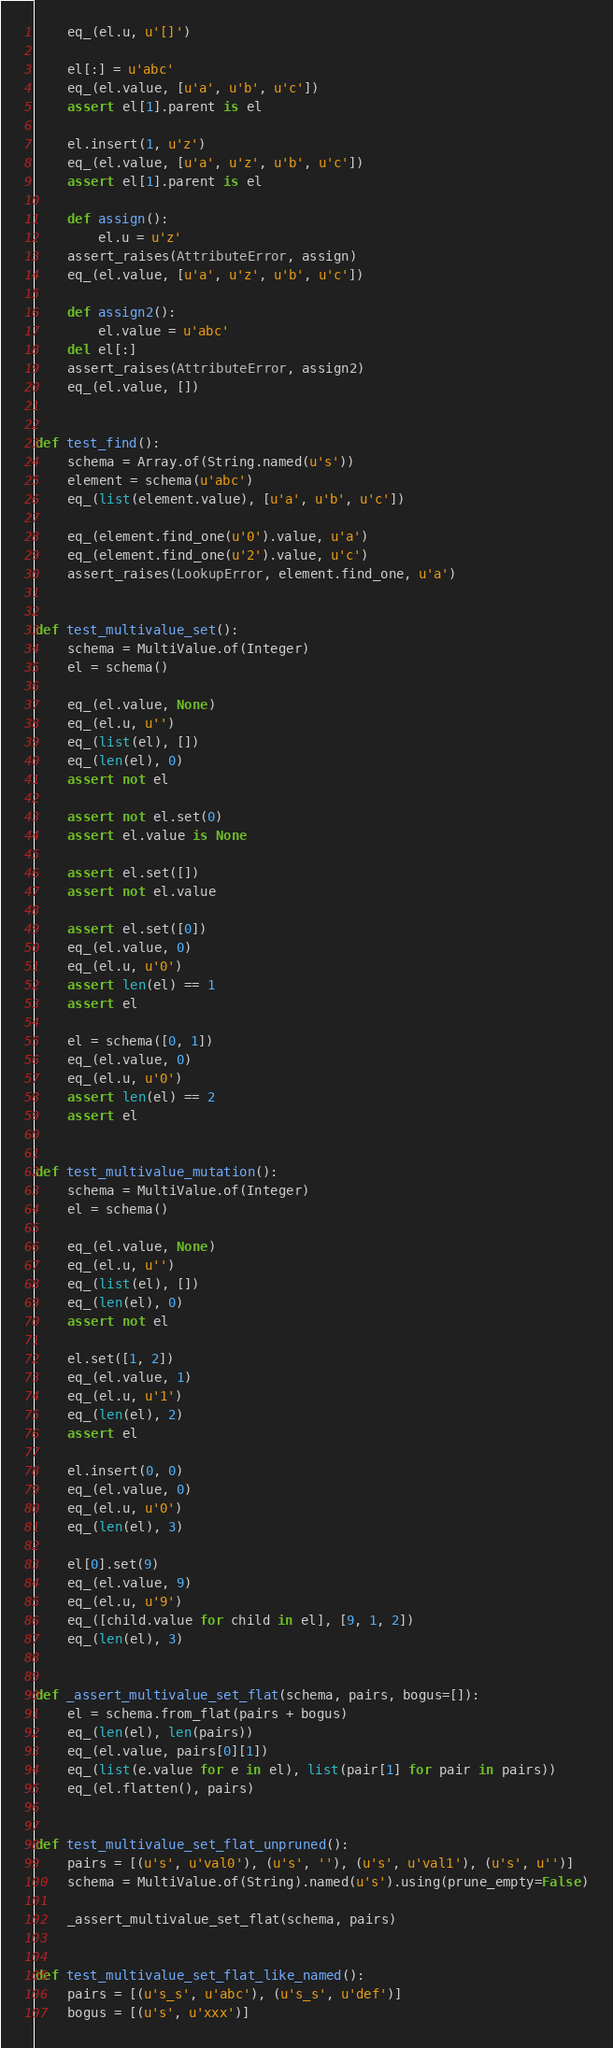<code> <loc_0><loc_0><loc_500><loc_500><_Python_>    eq_(el.u, u'[]')

    el[:] = u'abc'
    eq_(el.value, [u'a', u'b', u'c'])
    assert el[1].parent is el

    el.insert(1, u'z')
    eq_(el.value, [u'a', u'z', u'b', u'c'])
    assert el[1].parent is el

    def assign():
        el.u = u'z'
    assert_raises(AttributeError, assign)
    eq_(el.value, [u'a', u'z', u'b', u'c'])

    def assign2():
        el.value = u'abc'
    del el[:]
    assert_raises(AttributeError, assign2)
    eq_(el.value, [])


def test_find():
    schema = Array.of(String.named(u's'))
    element = schema(u'abc')
    eq_(list(element.value), [u'a', u'b', u'c'])

    eq_(element.find_one(u'0').value, u'a')
    eq_(element.find_one(u'2').value, u'c')
    assert_raises(LookupError, element.find_one, u'a')


def test_multivalue_set():
    schema = MultiValue.of(Integer)
    el = schema()

    eq_(el.value, None)
    eq_(el.u, u'')
    eq_(list(el), [])
    eq_(len(el), 0)
    assert not el

    assert not el.set(0)
    assert el.value is None

    assert el.set([])
    assert not el.value

    assert el.set([0])
    eq_(el.value, 0)
    eq_(el.u, u'0')
    assert len(el) == 1
    assert el

    el = schema([0, 1])
    eq_(el.value, 0)
    eq_(el.u, u'0')
    assert len(el) == 2
    assert el


def test_multivalue_mutation():
    schema = MultiValue.of(Integer)
    el = schema()

    eq_(el.value, None)
    eq_(el.u, u'')
    eq_(list(el), [])
    eq_(len(el), 0)
    assert not el

    el.set([1, 2])
    eq_(el.value, 1)
    eq_(el.u, u'1')
    eq_(len(el), 2)
    assert el

    el.insert(0, 0)
    eq_(el.value, 0)
    eq_(el.u, u'0')
    eq_(len(el), 3)

    el[0].set(9)
    eq_(el.value, 9)
    eq_(el.u, u'9')
    eq_([child.value for child in el], [9, 1, 2])
    eq_(len(el), 3)


def _assert_multivalue_set_flat(schema, pairs, bogus=[]):
    el = schema.from_flat(pairs + bogus)
    eq_(len(el), len(pairs))
    eq_(el.value, pairs[0][1])
    eq_(list(e.value for e in el), list(pair[1] for pair in pairs))
    eq_(el.flatten(), pairs)


def test_multivalue_set_flat_unpruned():
    pairs = [(u's', u'val0'), (u's', ''), (u's', u'val1'), (u's', u'')]
    schema = MultiValue.of(String).named(u's').using(prune_empty=False)

    _assert_multivalue_set_flat(schema, pairs)


def test_multivalue_set_flat_like_named():
    pairs = [(u's_s', u'abc'), (u's_s', u'def')]
    bogus = [(u's', u'xxx')]</code> 